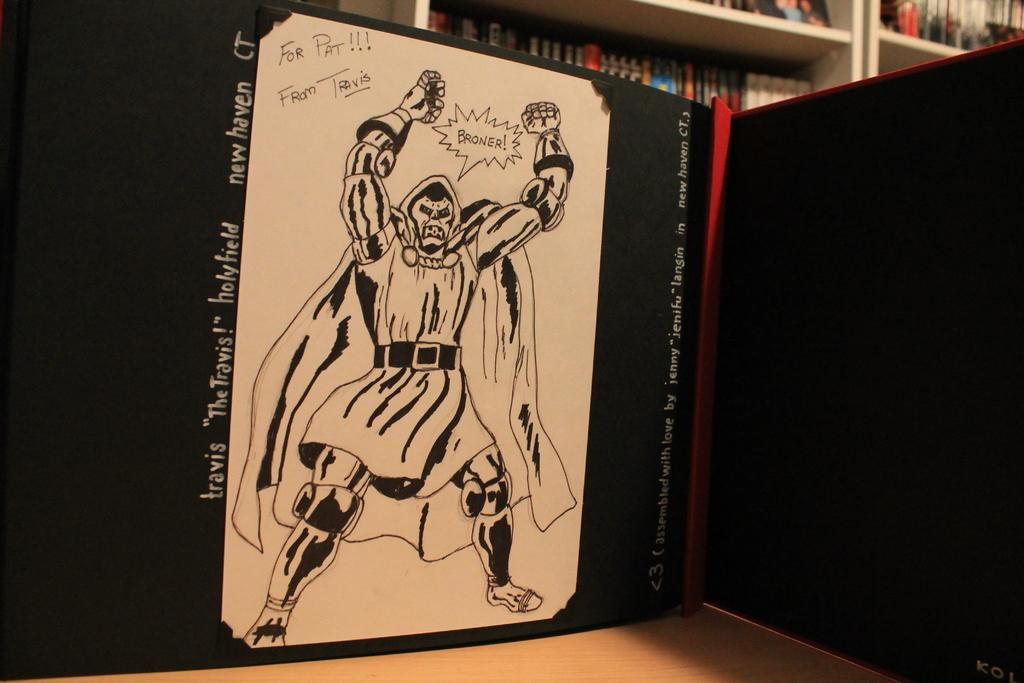<image>
Share a concise interpretation of the image provided. A comic book character by Travis Holyfield yells "Broner." 